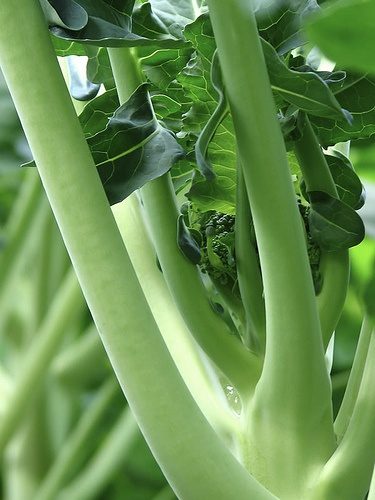Describe the objects in this image and their specific colors. I can see broccoli in olive, green, and darkgreen tones, broccoli in olive and darkgreen tones, broccoli in olive and darkgreen tones, and broccoli in olive, green, and darkgreen tones in this image. 